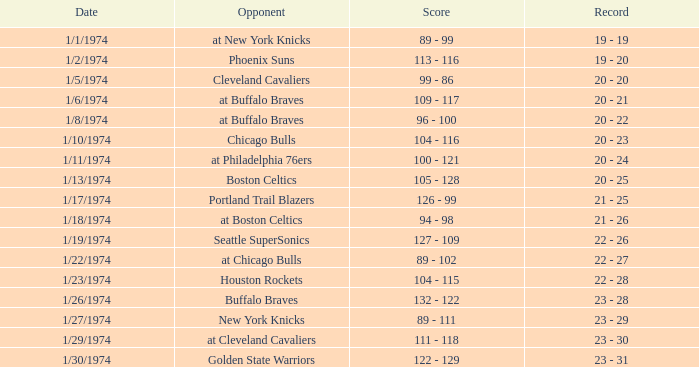What was the result on the 10th of january, 1974? 104 - 116. 